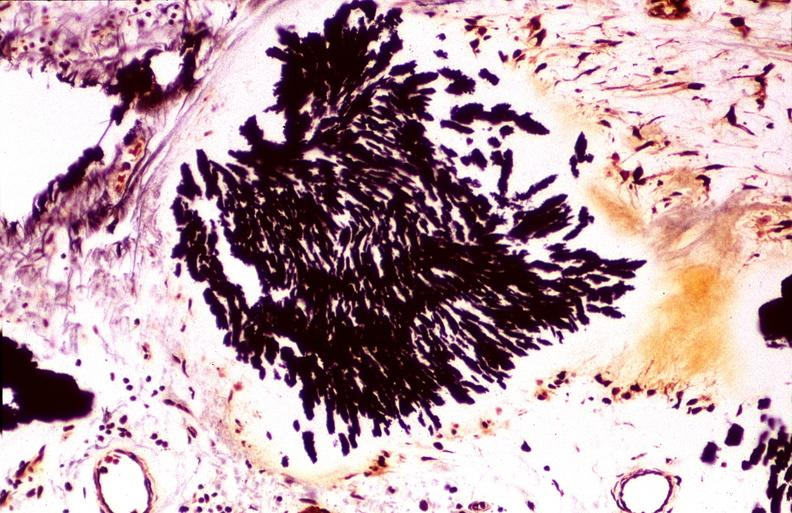s joints present?
Answer the question using a single word or phrase. Yes 